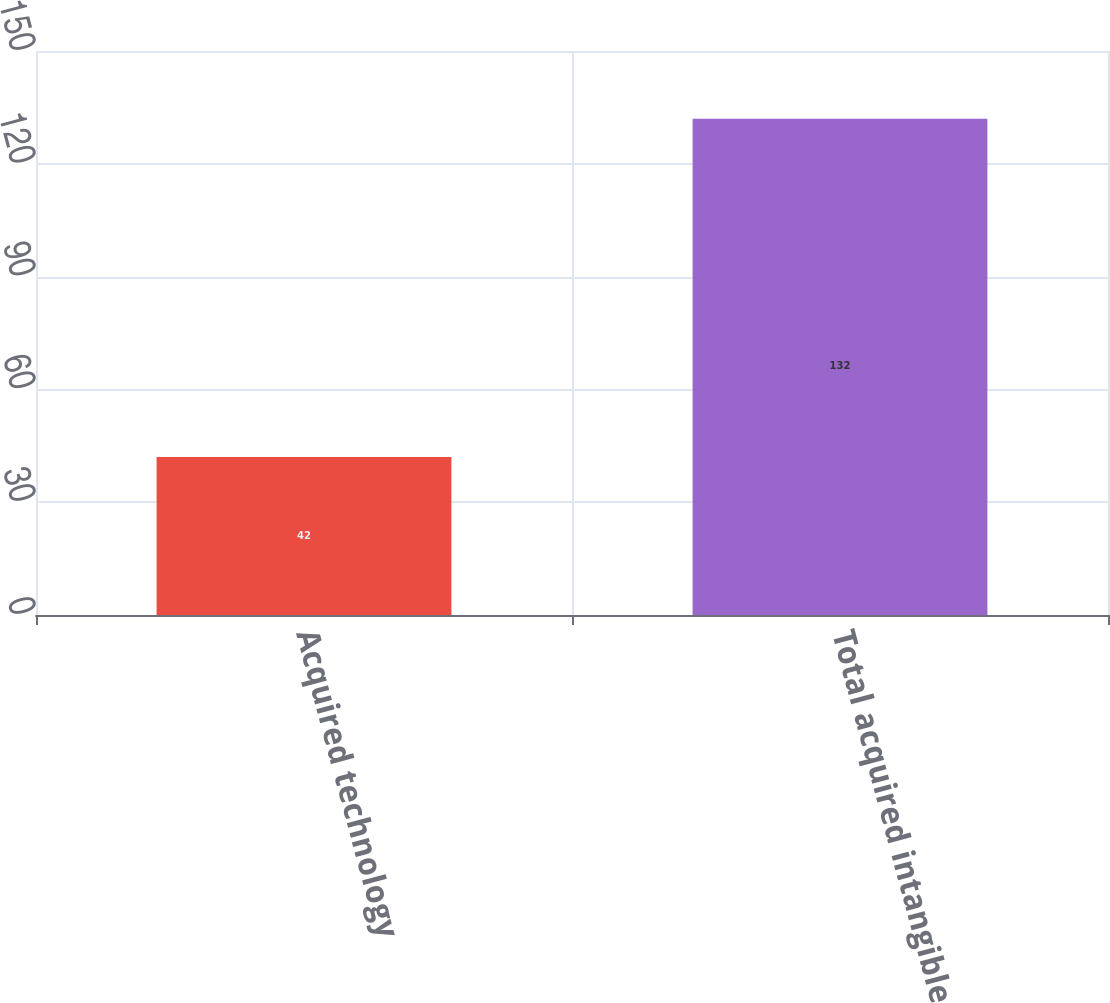<chart> <loc_0><loc_0><loc_500><loc_500><bar_chart><fcel>Acquired technology<fcel>Total acquired intangible<nl><fcel>42<fcel>132<nl></chart> 